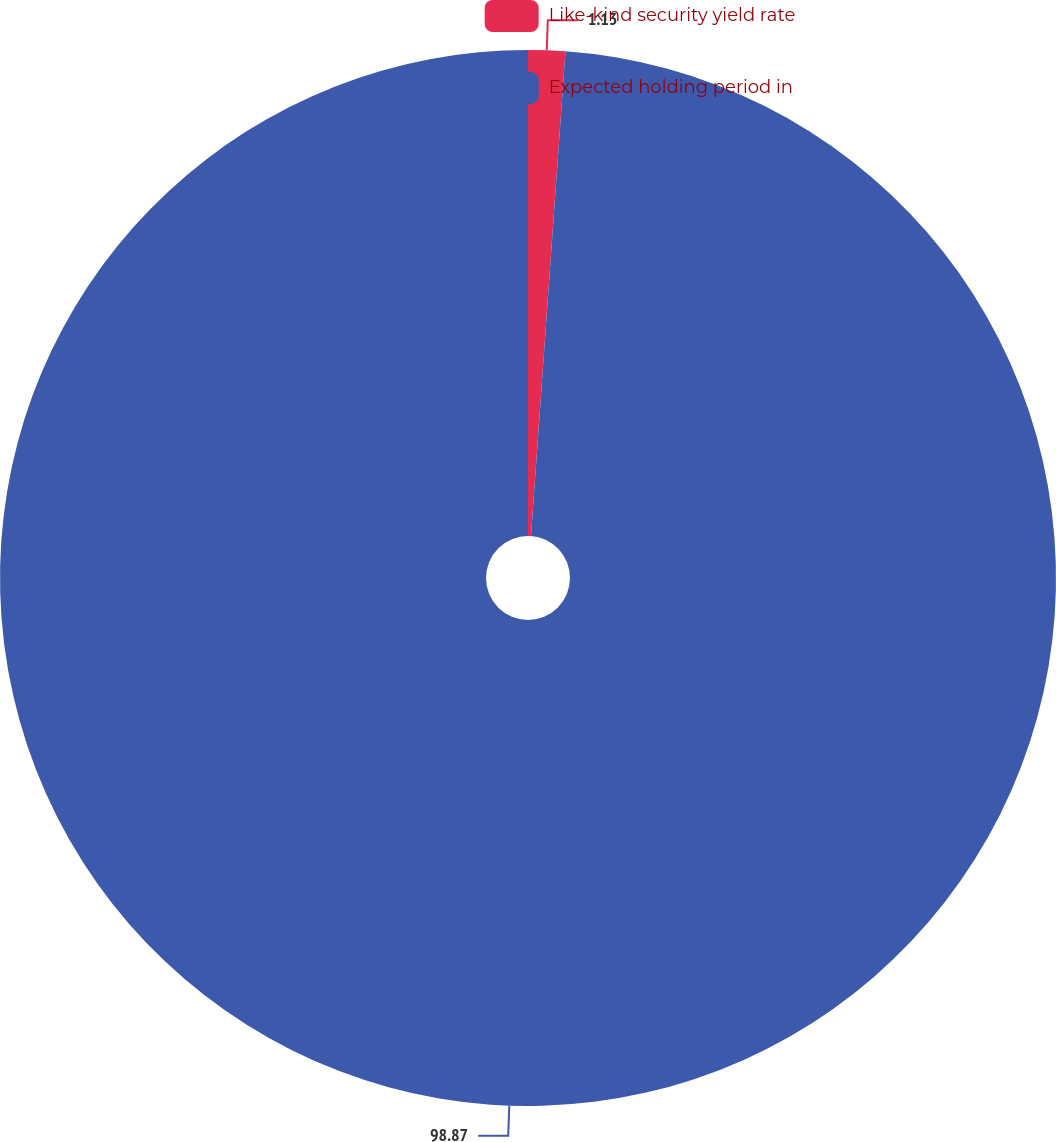<chart> <loc_0><loc_0><loc_500><loc_500><pie_chart><fcel>Like-kind security yield rate<fcel>Expected holding period in<nl><fcel>1.13%<fcel>98.87%<nl></chart> 